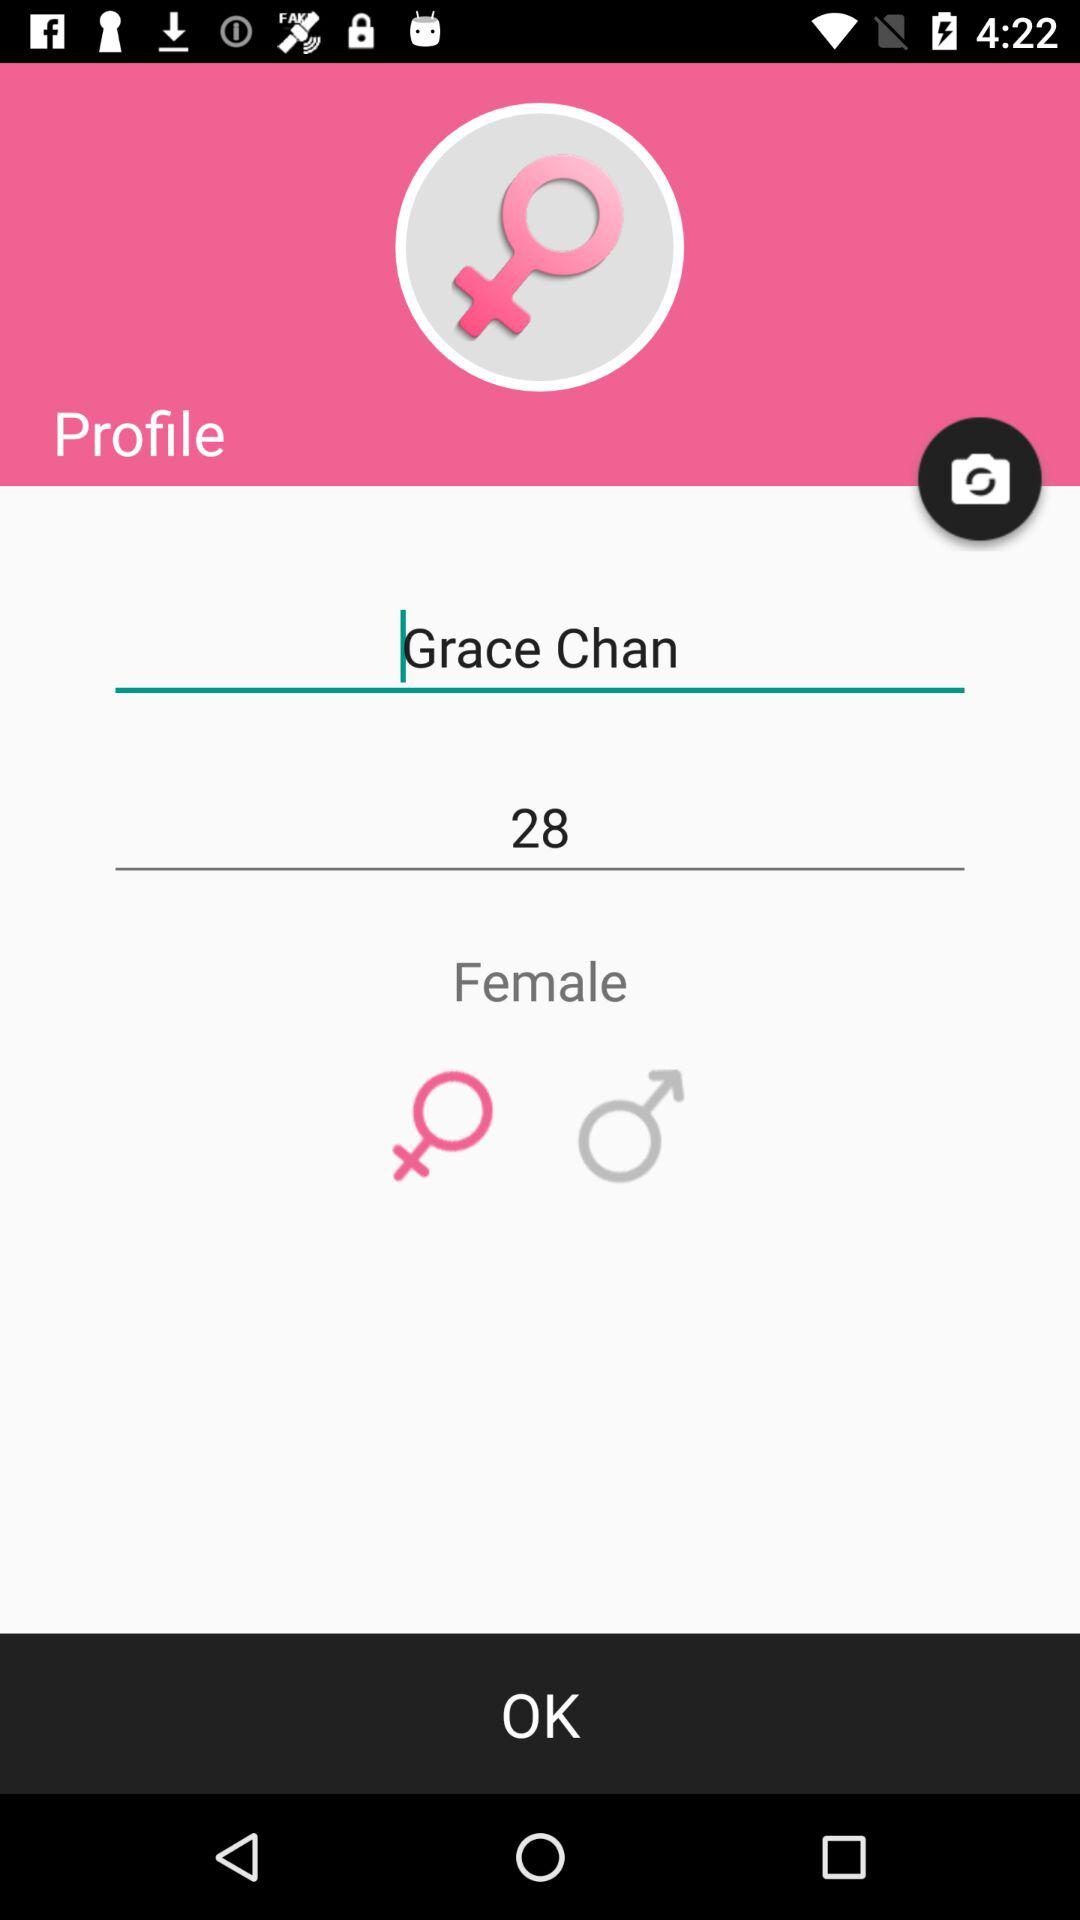What is the name of the user? The name of the user is Grace Chan. 